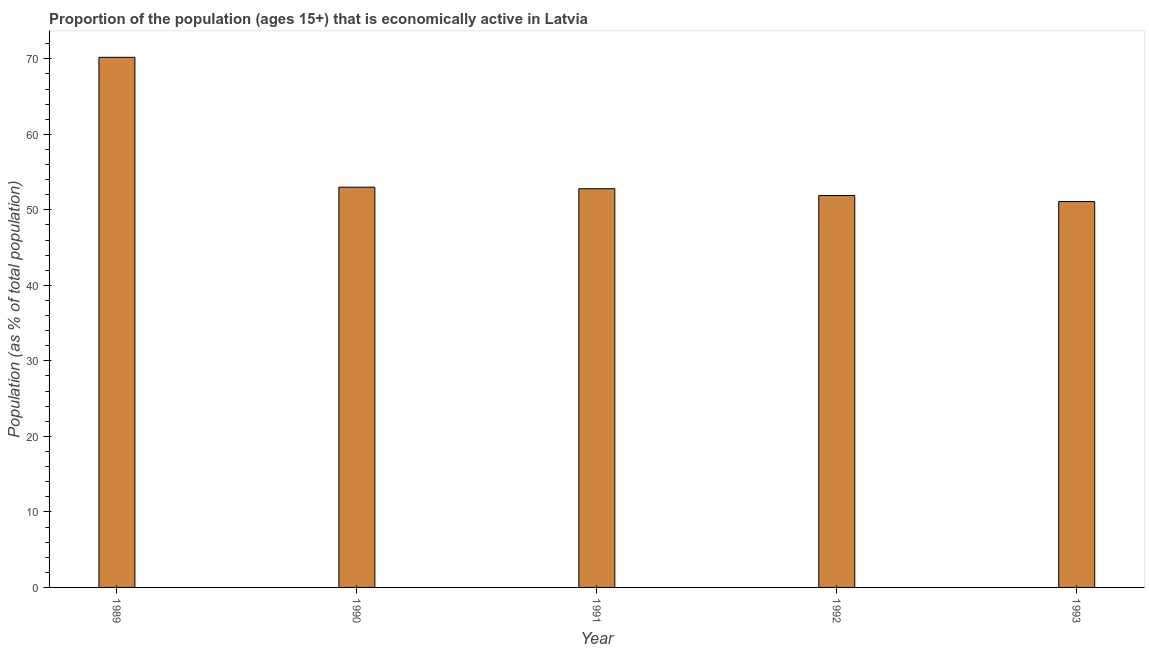Does the graph contain any zero values?
Offer a terse response. No. What is the title of the graph?
Your response must be concise. Proportion of the population (ages 15+) that is economically active in Latvia. What is the label or title of the X-axis?
Provide a short and direct response. Year. What is the label or title of the Y-axis?
Your answer should be compact. Population (as % of total population). Across all years, what is the maximum percentage of economically active population?
Offer a terse response. 70.2. Across all years, what is the minimum percentage of economically active population?
Offer a very short reply. 51.1. In which year was the percentage of economically active population maximum?
Your response must be concise. 1989. What is the sum of the percentage of economically active population?
Provide a short and direct response. 279. What is the difference between the percentage of economically active population in 1989 and 1992?
Your response must be concise. 18.3. What is the average percentage of economically active population per year?
Offer a terse response. 55.8. What is the median percentage of economically active population?
Provide a succinct answer. 52.8. Do a majority of the years between 1991 and 1989 (inclusive) have percentage of economically active population greater than 70 %?
Offer a very short reply. Yes. What is the ratio of the percentage of economically active population in 1989 to that in 1993?
Provide a short and direct response. 1.37. Is the percentage of economically active population in 1989 less than that in 1990?
Provide a succinct answer. No. Is the difference between the percentage of economically active population in 1992 and 1993 greater than the difference between any two years?
Provide a succinct answer. No. What is the difference between the highest and the lowest percentage of economically active population?
Give a very brief answer. 19.1. In how many years, is the percentage of economically active population greater than the average percentage of economically active population taken over all years?
Ensure brevity in your answer.  1. Are all the bars in the graph horizontal?
Offer a very short reply. No. How many years are there in the graph?
Give a very brief answer. 5. What is the difference between two consecutive major ticks on the Y-axis?
Provide a short and direct response. 10. What is the Population (as % of total population) of 1989?
Give a very brief answer. 70.2. What is the Population (as % of total population) of 1991?
Ensure brevity in your answer.  52.8. What is the Population (as % of total population) of 1992?
Offer a terse response. 51.9. What is the Population (as % of total population) in 1993?
Your response must be concise. 51.1. What is the difference between the Population (as % of total population) in 1989 and 1992?
Give a very brief answer. 18.3. What is the difference between the Population (as % of total population) in 1989 and 1993?
Your answer should be very brief. 19.1. What is the difference between the Population (as % of total population) in 1990 and 1991?
Your answer should be compact. 0.2. What is the difference between the Population (as % of total population) in 1992 and 1993?
Offer a very short reply. 0.8. What is the ratio of the Population (as % of total population) in 1989 to that in 1990?
Your answer should be compact. 1.32. What is the ratio of the Population (as % of total population) in 1989 to that in 1991?
Offer a terse response. 1.33. What is the ratio of the Population (as % of total population) in 1989 to that in 1992?
Offer a very short reply. 1.35. What is the ratio of the Population (as % of total population) in 1989 to that in 1993?
Offer a very short reply. 1.37. What is the ratio of the Population (as % of total population) in 1990 to that in 1991?
Make the answer very short. 1. What is the ratio of the Population (as % of total population) in 1991 to that in 1993?
Provide a short and direct response. 1.03. What is the ratio of the Population (as % of total population) in 1992 to that in 1993?
Your answer should be compact. 1.02. 